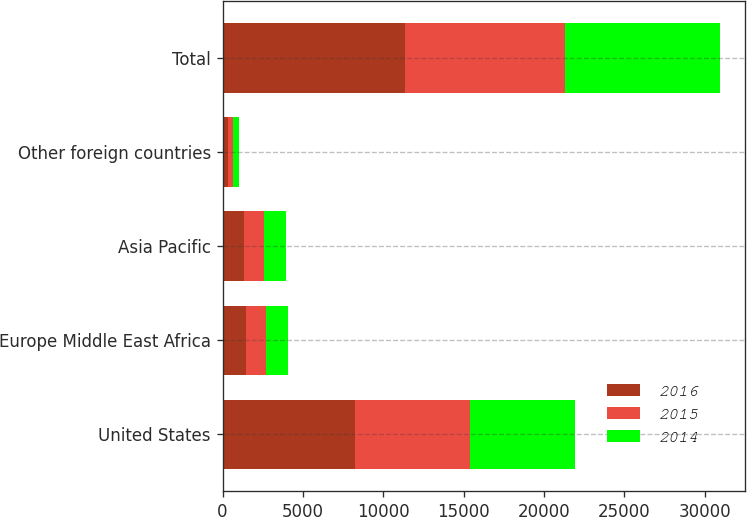Convert chart to OTSL. <chart><loc_0><loc_0><loc_500><loc_500><stacked_bar_chart><ecel><fcel>United States<fcel>Europe Middle East Africa<fcel>Asia Pacific<fcel>Other foreign countries<fcel>Total<nl><fcel>2016<fcel>8247<fcel>1442<fcel>1314<fcel>322<fcel>11325<nl><fcel>2015<fcel>7116<fcel>1267<fcel>1251<fcel>312<fcel>9946<nl><fcel>2014<fcel>6558<fcel>1371<fcel>1368<fcel>378<fcel>9675<nl></chart> 